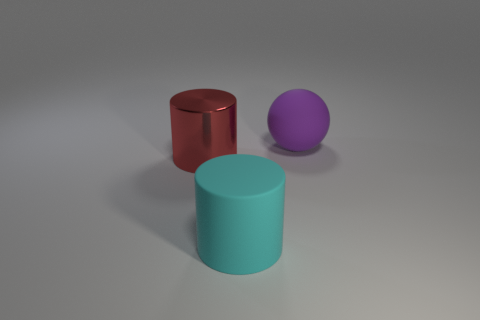There is a purple rubber object that is the same size as the cyan matte cylinder; what is its shape?
Your answer should be compact. Sphere. Is there a shiny object of the same shape as the cyan matte thing?
Make the answer very short. Yes. Does the matte thing that is in front of the purple sphere have the same size as the red thing?
Provide a short and direct response. Yes. What is the size of the object that is behind the big cyan object and in front of the purple object?
Keep it short and to the point. Large. What number of other things are there of the same material as the sphere
Ensure brevity in your answer.  1. There is a rubber object that is in front of the big purple ball; what is its size?
Provide a short and direct response. Large. Is the rubber cylinder the same color as the metal object?
Ensure brevity in your answer.  No. How many large objects are either red metallic cylinders or rubber things?
Provide a succinct answer. 3. Is there any other thing that is the same color as the ball?
Offer a terse response. No. There is a cyan cylinder; are there any large matte cylinders on the right side of it?
Give a very brief answer. No. 